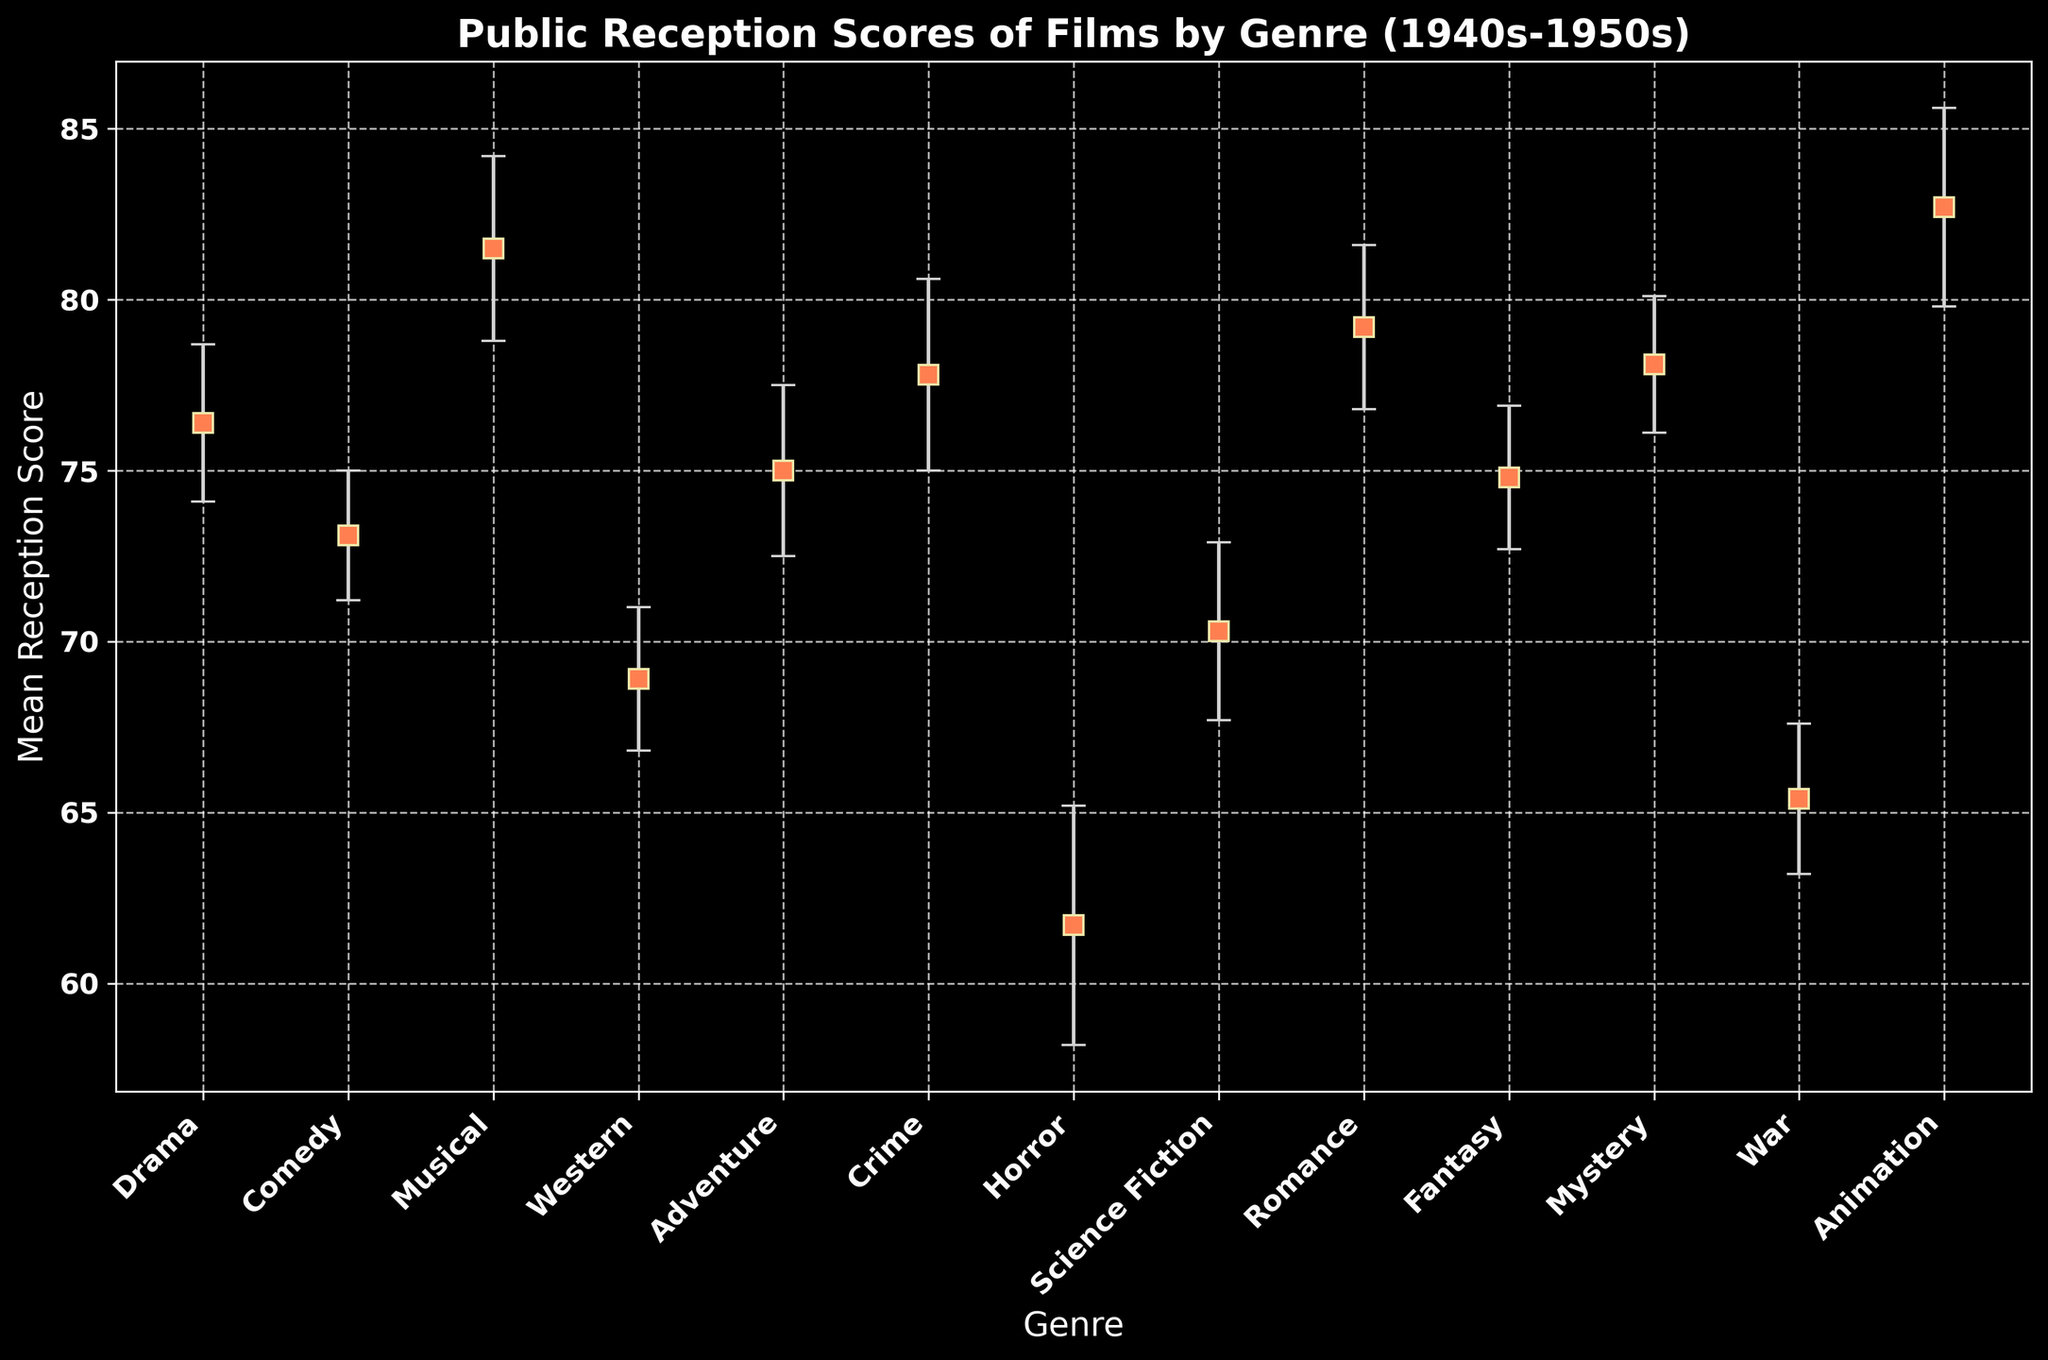Which genre has the highest mean reception score? By looking at the highest point on the y-axis, we can see that the genre with the highest mean reception score is labeled "Animation".
Answer: Animation Which genre has the lowest mean reception score? By identifying the lowest point on the y-axis, we see that the genre with the lowest mean reception score is labeled "Horror".
Answer: Horror What is the difference in mean reception score between Musical and War genres? The mean score for Musical is 81.5 and for War is 65.4. The difference is calculated as 81.5 - 65.4 = 16.1.
Answer: 16.1 Which genre has a reception score closest to 75? Looking at the genres with mean reception scores around 75, we find that both Adventure (75.0) and Fantasy (74.8) are closest compared to other genres.
Answer: Adventure and Fantasy What is the average mean reception score of Drama, Comedy, and Musical genres? The scores are 76.4, 73.1, and 81.5 respectively. The average is calculated as (76.4 + 73.1 + 81.5) / 3 = 230.999 / 3 ≈ 77.0.
Answer: 77.0 Which genre has the largest error margin in the figure? By comparing the error margins, the largest one is 3.5, which corresponds to the Horror genre.
Answer: Horror How much higher is the mean score for Romance compared to Science Fiction? The mean score for Romance is 79.2 and for Science Fiction is 70.3. Thus, the difference is 79.2 - 70.3 = 8.9.
Answer: 8.9 What is the mean reception score range for Crime movies? The mean score for Crime is 77.8 with an error margin of 2.8. The range is 77.8 ± 2.8, resulting in [75.0, 80.6].
Answer: [75.0, 80.6] Which genre has a higher mean reception score, Mystery or Western? The mean score for Mystery is 78.1 and for Western, it is 68.9. Since 78.1 is greater than 68.9, Mystery has a higher mean score.
Answer: Mystery What is the combined error margin of Drama, Comedy, and Western genres? The error margins are 2.3, 1.9, and 2.1, respectively. Summing these values gives 2.3 + 1.9 + 2.1 = 6.3.
Answer: 6.3 